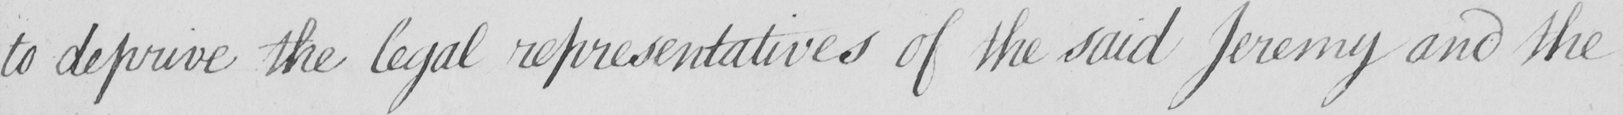Can you tell me what this handwritten text says? to deprive the legal representatives of the said Jeremy and the 